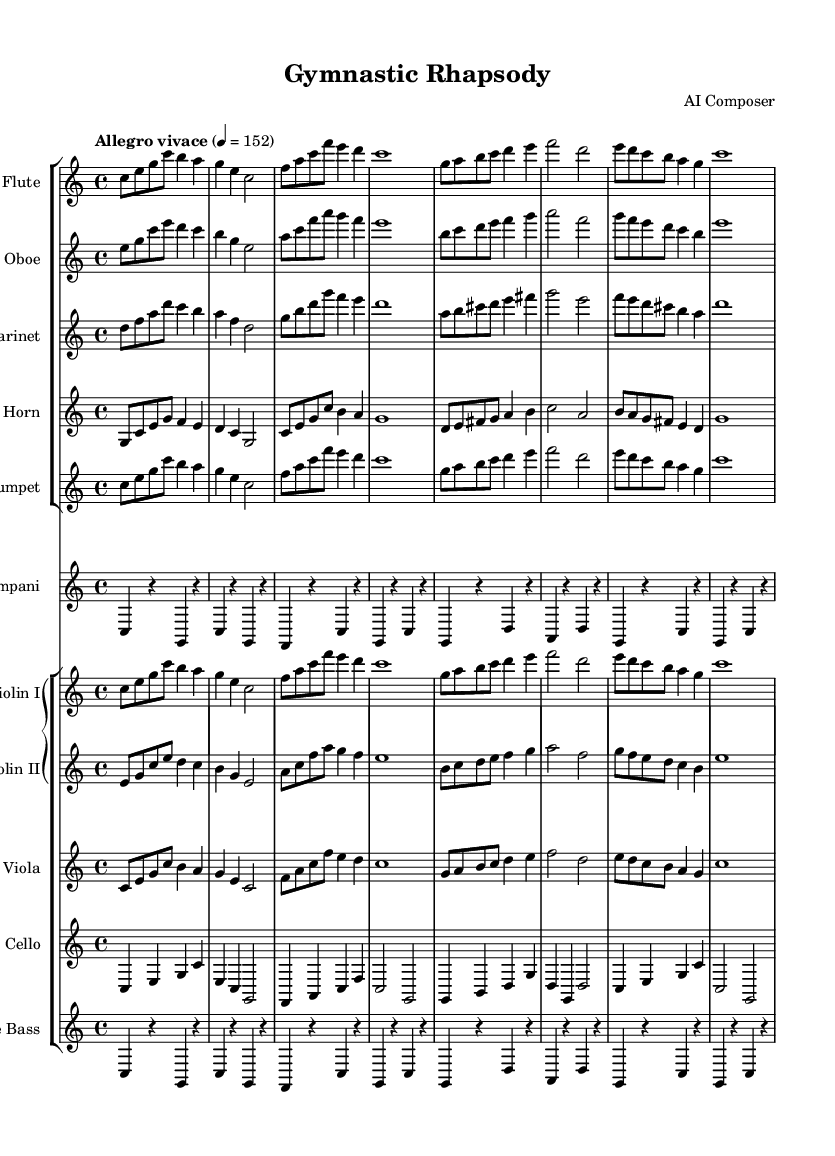What is the key signature of this music? The key signature is C major, indicated at the beginning of the score with no sharps or flats.
Answer: C major What is the time signature of the piece? The time signature is displayed as 4/4 at the start of the score, indicating four beats per measure.
Answer: 4/4 What is the tempo marking of the music? The tempo is marked as "Allegro vivace," which suggests a lively and fast pace, with a specific metronome marking of 152 beats per minute.
Answer: Allegro vivace How many measures does the flute part contain? By counting the measures in the flute part, including the rests, we find that there are a total of 8 measures in this section.
Answer: 8 Which instruments are included in the woodwind section? The woodwind section consists of the flute, oboe, clarinet, and horn, as indicated by the corresponding staves in the score.
Answer: Flute, oboe, clarinet, horn What dynamic markings are present in the music? Although dynamic markings are not explicitly shown in the provided score, "Allegro vivace" implies a lively and energetic character typically performed at a forte dynamic.
Answer: Forte (implied) Is this piece suitable for a display of gymnastics floor routines? The energetic tempo and lively character of the music suggest it is well-suited for rhythmic and dynamic activities such as gymnastics floor routines.
Answer: Yes 